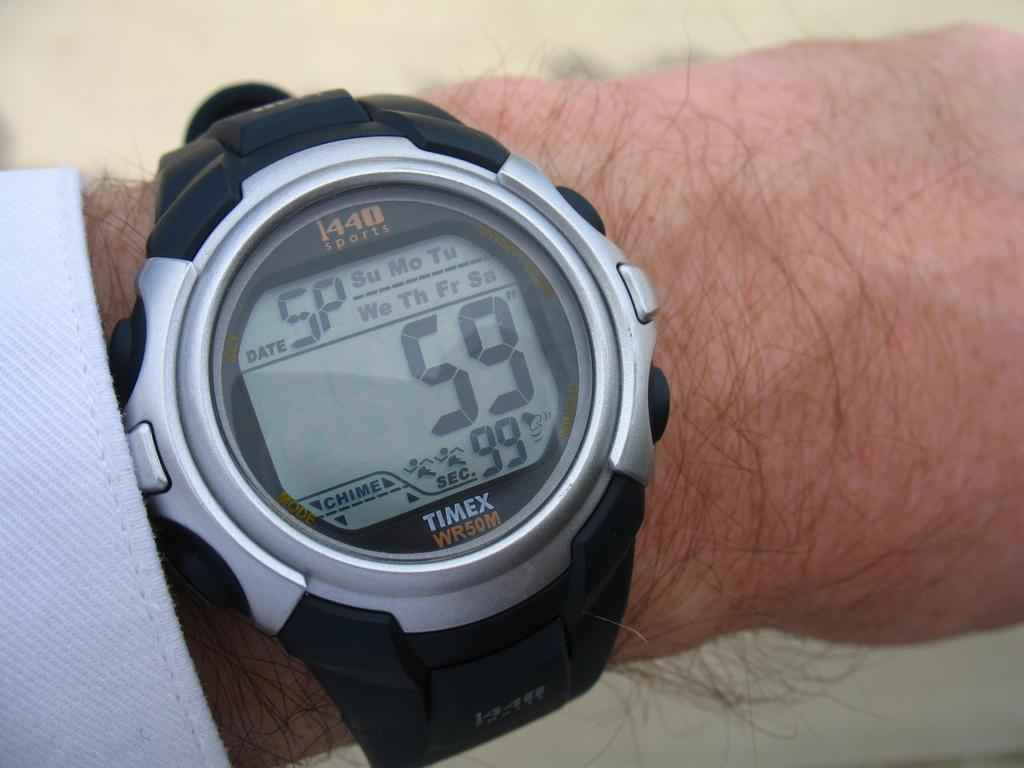<image>
Present a compact description of the photo's key features. A Timex wrist watch is in stop watch mode with 59 seconds left on the clock. 